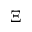Convert formula to latex. <formula><loc_0><loc_0><loc_500><loc_500>\Xi</formula> 